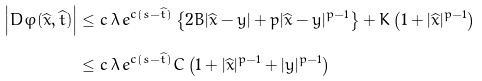Convert formula to latex. <formula><loc_0><loc_0><loc_500><loc_500>\left | D \varphi ( \widehat { x } , \widehat { t } ) \right | & \leq c \, \lambda \, e ^ { c ( s - \widehat { t } ) } \left \{ 2 B | \widehat { x } - y | + p | \widehat { x } - y | ^ { p - 1 } \right \} + K \left ( 1 + | \widehat { x } | ^ { p - 1 } \right ) \\ & \leq c \, \lambda \, e ^ { c ( s - \widehat { t } ) } C \left ( 1 + | \widehat { x } | ^ { p - 1 } + | y | ^ { p - 1 } \right )</formula> 